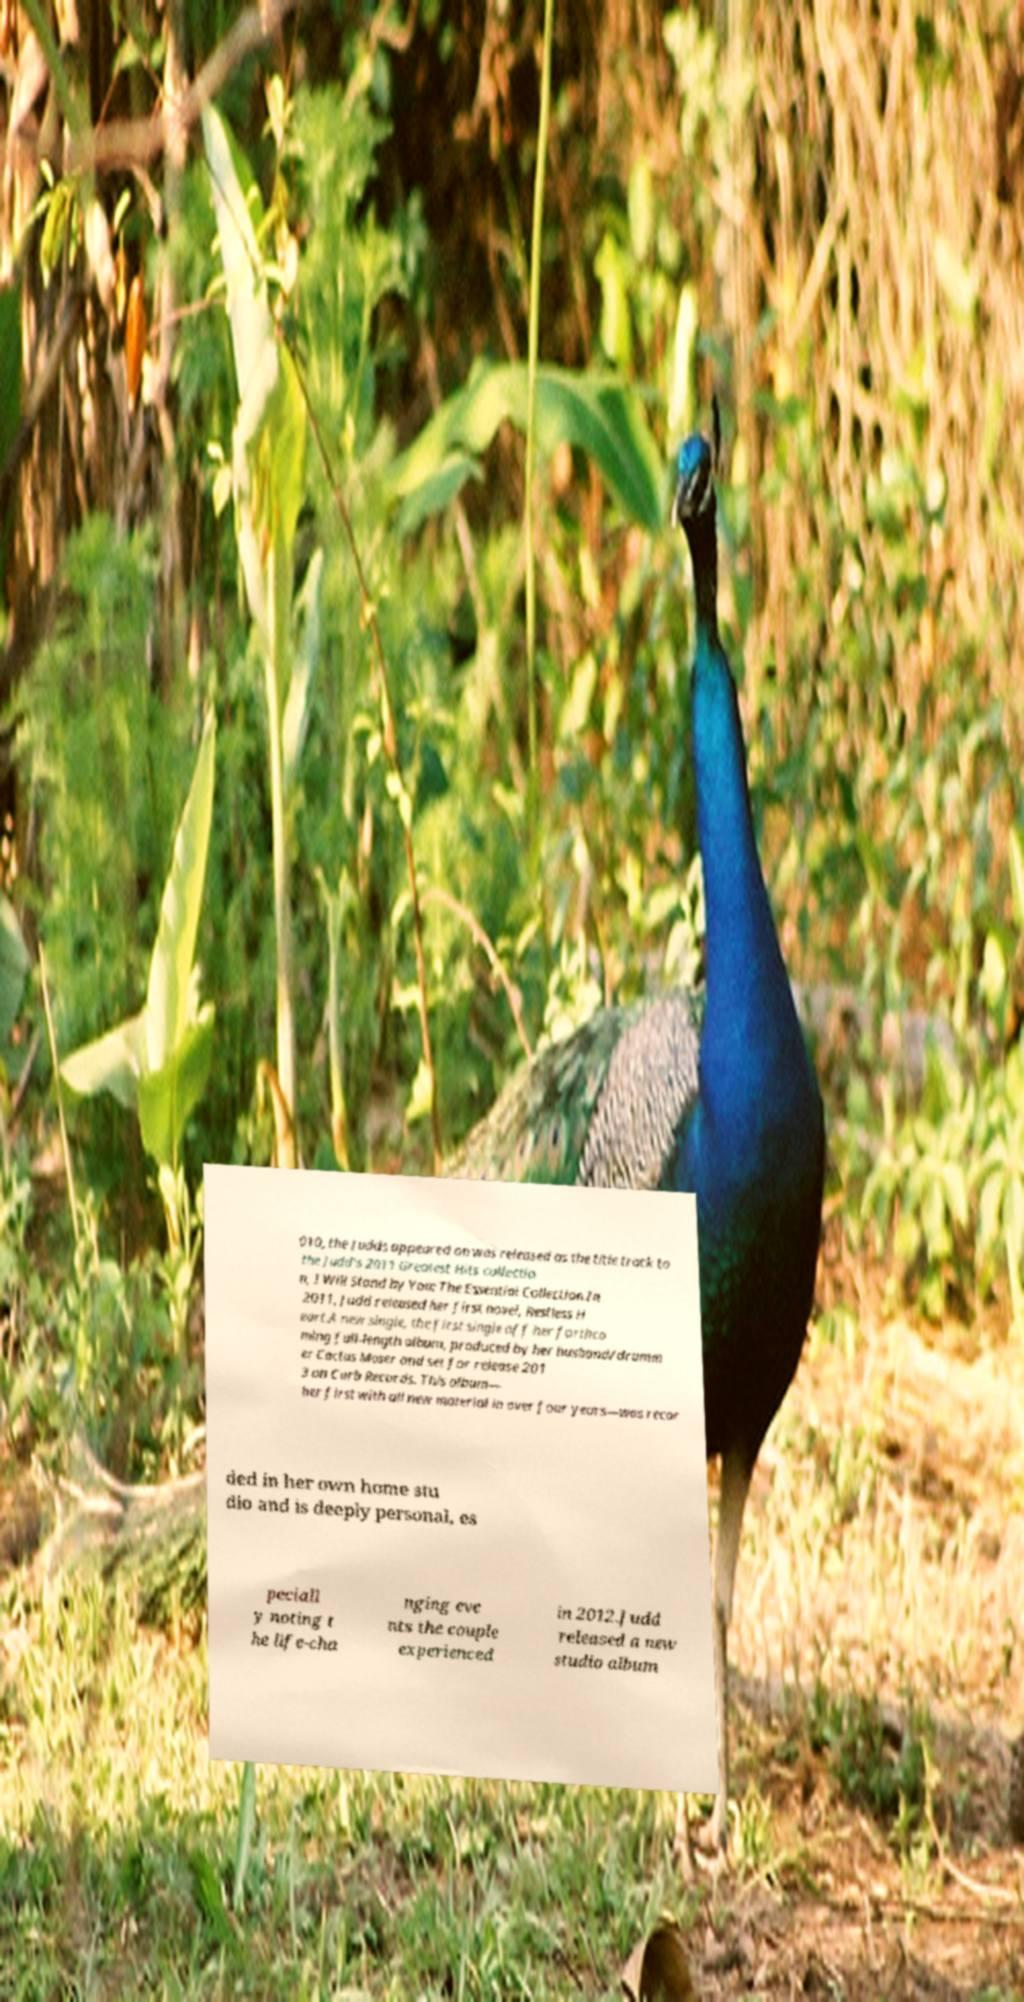I need the written content from this picture converted into text. Can you do that? 010, the Judds appeared on was released as the title track to the Judd's 2011 Greatest Hits collectio n, I Will Stand by You: The Essential Collection.In 2011, Judd released her first novel, Restless H eart.A new single, the first single off her forthco ming full-length album, produced by her husband/drumm er Cactus Moser and set for release 201 3 on Curb Records. This album— her first with all new material in over four years—was recor ded in her own home stu dio and is deeply personal, es peciall y noting t he life-cha nging eve nts the couple experienced in 2012.Judd released a new studio album 